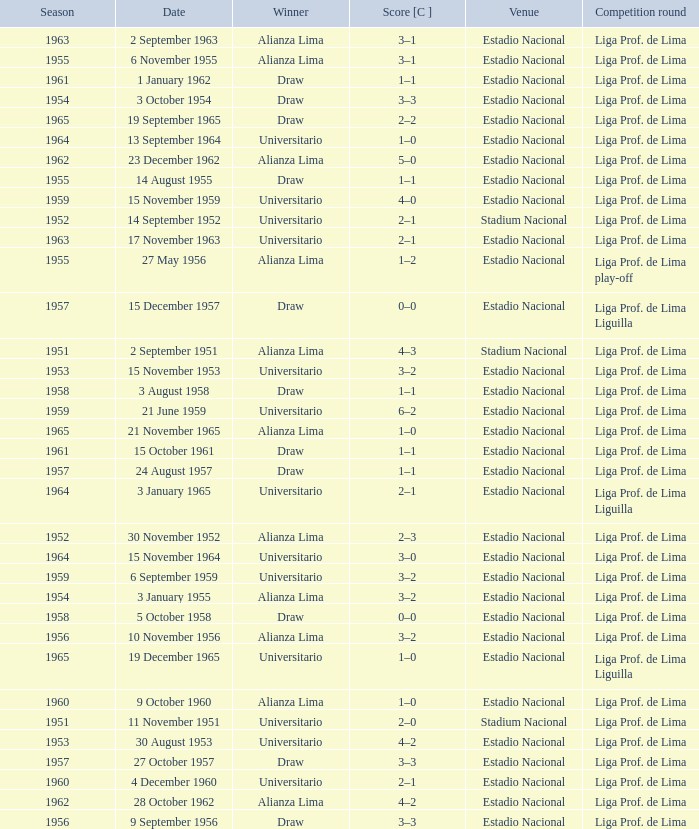What is the most recent season with a date of 27 October 1957? 1957.0. 